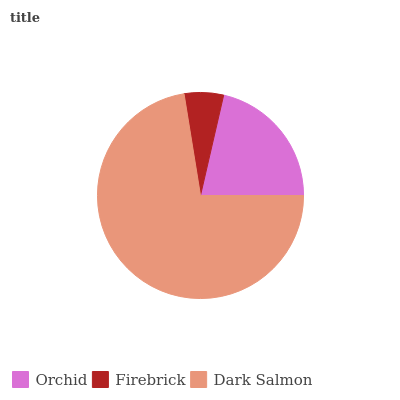Is Firebrick the minimum?
Answer yes or no. Yes. Is Dark Salmon the maximum?
Answer yes or no. Yes. Is Dark Salmon the minimum?
Answer yes or no. No. Is Firebrick the maximum?
Answer yes or no. No. Is Dark Salmon greater than Firebrick?
Answer yes or no. Yes. Is Firebrick less than Dark Salmon?
Answer yes or no. Yes. Is Firebrick greater than Dark Salmon?
Answer yes or no. No. Is Dark Salmon less than Firebrick?
Answer yes or no. No. Is Orchid the high median?
Answer yes or no. Yes. Is Orchid the low median?
Answer yes or no. Yes. Is Dark Salmon the high median?
Answer yes or no. No. Is Firebrick the low median?
Answer yes or no. No. 